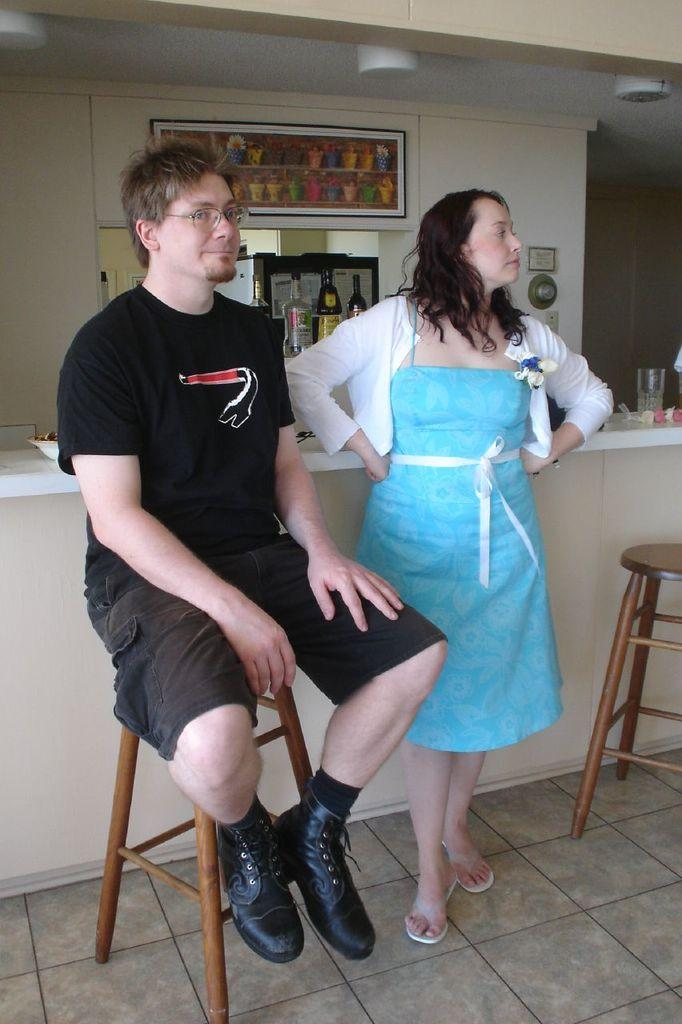How many people are in the image? There are two persons in the image. What is one person doing in the image? One person is sitting on the table. What type of objects can be seen in the image? There are bottles and a glass visible in the image. How many eggs are visible in the image? There are no eggs present in the image. What type of bottle is the person holding in the image? There is no person holding a bottle in the image. 